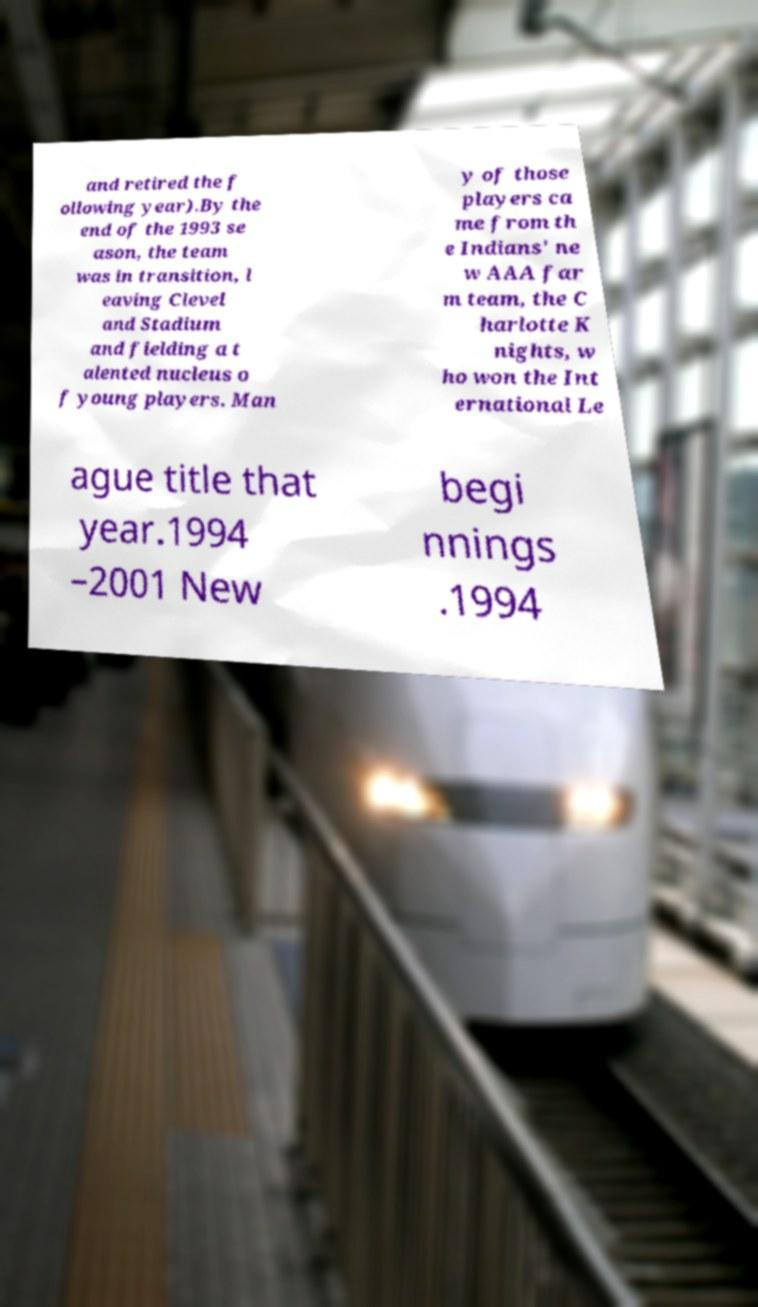For documentation purposes, I need the text within this image transcribed. Could you provide that? and retired the f ollowing year).By the end of the 1993 se ason, the team was in transition, l eaving Clevel and Stadium and fielding a t alented nucleus o f young players. Man y of those players ca me from th e Indians' ne w AAA far m team, the C harlotte K nights, w ho won the Int ernational Le ague title that year.1994 –2001 New begi nnings .1994 